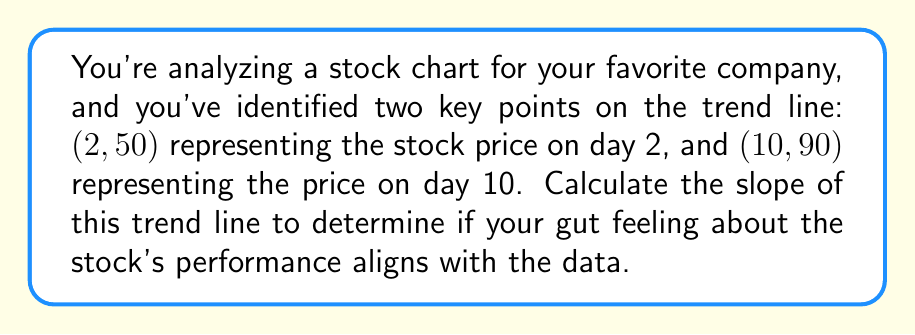Solve this math problem. To calculate the slope of a trend line, we use the formula:

$$ m = \frac{y_2 - y_1}{x_2 - x_1} $$

Where:
- $(x_1, y_1)$ is the first point (2, 50)
- $(x_2, y_2)$ is the second point (10, 90)

Let's plug in the values:

$$ m = \frac{90 - 50}{10 - 2} $$

Simplifying:

$$ m = \frac{40}{8} $$

$$ m = 5 $$

The slope of 5 indicates that for each day that passes (x-axis), the stock price increases by $5 (y-axis).

This positive slope suggests an upward trend in the stock price, which may confirm your instinct if you were feeling bullish about the stock. However, it's important to note that past performance doesn't guarantee future results, and relying solely on instinct and emotion in day trading can be risky.
Answer: The slope of the trend line is 5. 